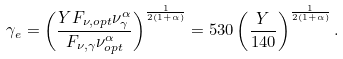Convert formula to latex. <formula><loc_0><loc_0><loc_500><loc_500>\gamma _ { e } = \left ( \frac { Y F _ { \nu , o p t } \nu _ { \gamma } ^ { \alpha } } { F _ { \nu , \gamma } \nu _ { o p t } ^ { \alpha } } \right ) ^ { \frac { 1 } { 2 ( 1 + \alpha ) } } = 5 3 0 \left ( \frac { Y } { 1 4 0 } \right ) ^ { \frac { 1 } { 2 ( 1 + \alpha ) } } .</formula> 